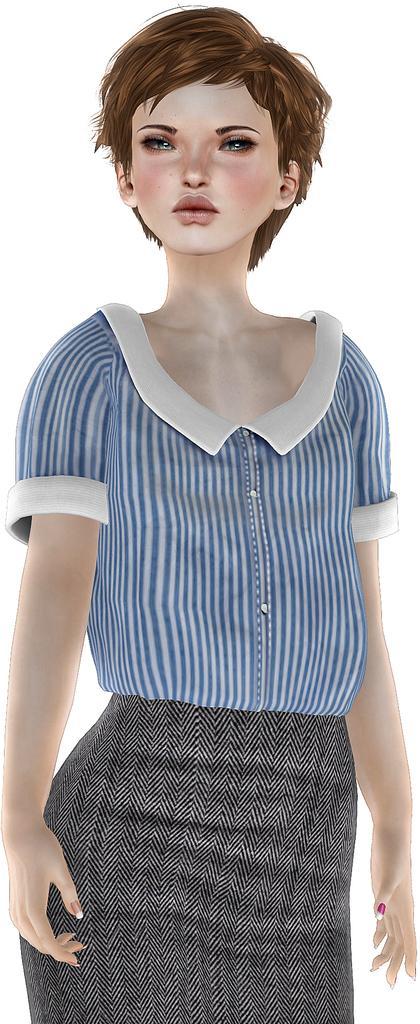Could you give a brief overview of what you see in this image? This is an animated image, in this picture there is a woman standing. In the background of the image it is white. 